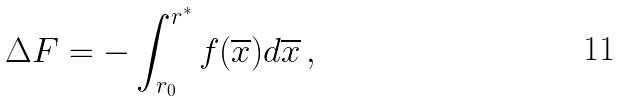<formula> <loc_0><loc_0><loc_500><loc_500>\Delta F = - \int _ { { r } _ { 0 } } ^ { { r } ^ { * } } { f } ( \overline { x } ) d \overline { x } \, ,</formula> 